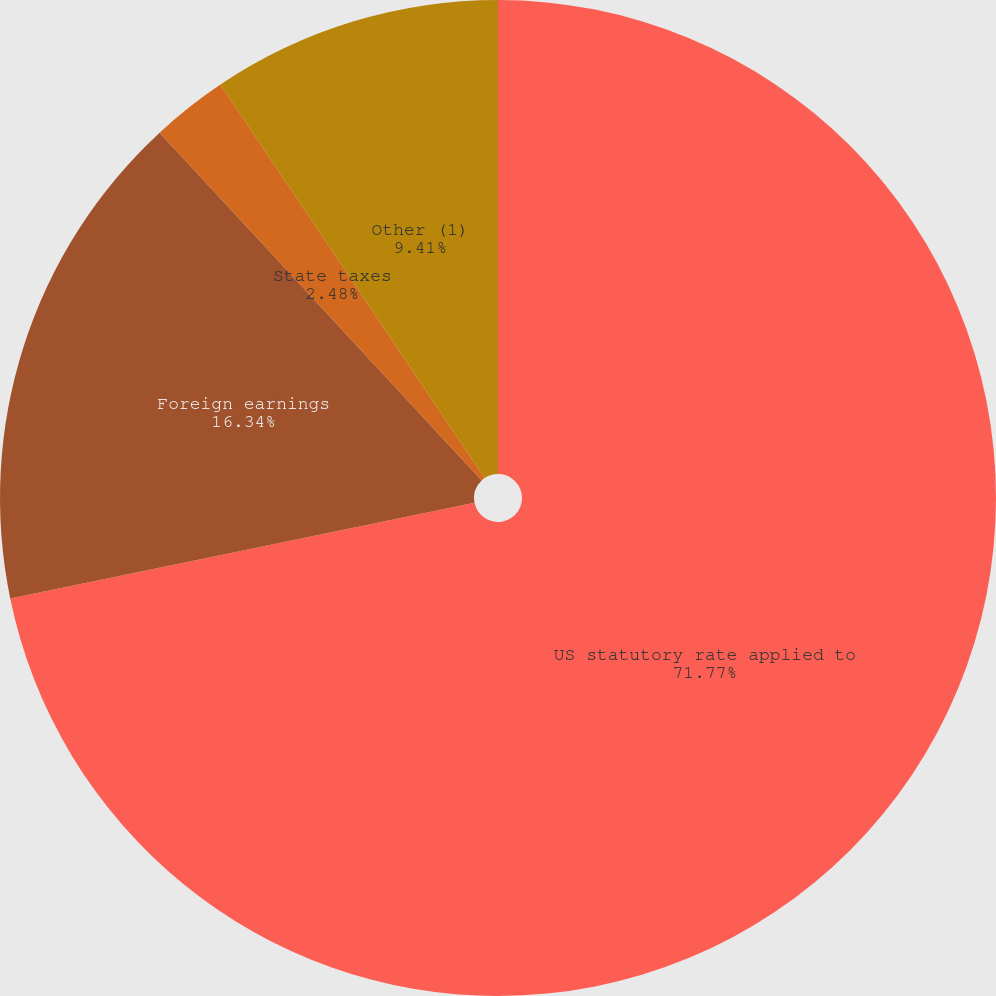<chart> <loc_0><loc_0><loc_500><loc_500><pie_chart><fcel>US statutory rate applied to<fcel>Foreign earnings<fcel>State taxes<fcel>Other (1)<nl><fcel>71.77%<fcel>16.34%<fcel>2.48%<fcel>9.41%<nl></chart> 